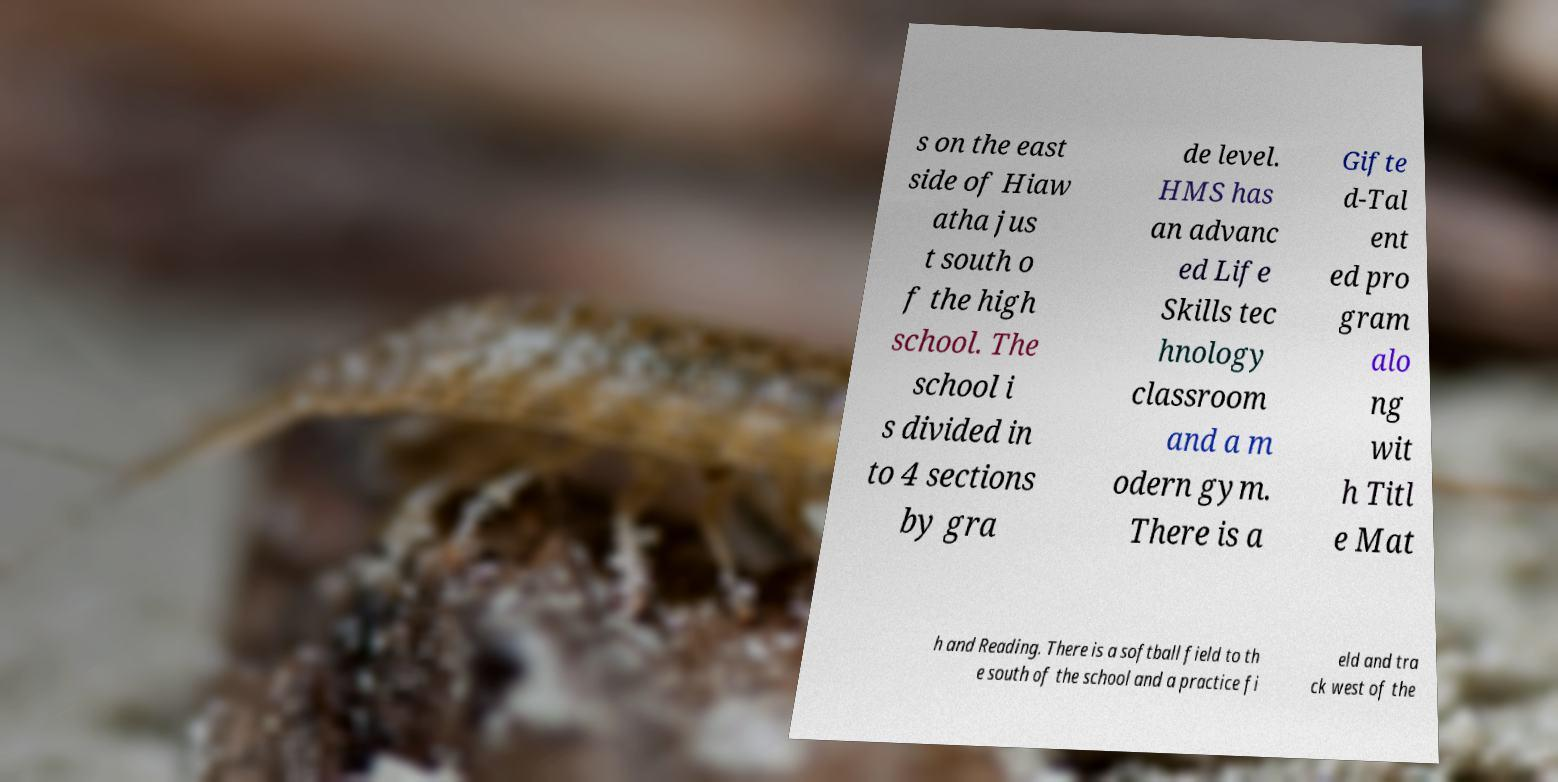There's text embedded in this image that I need extracted. Can you transcribe it verbatim? s on the east side of Hiaw atha jus t south o f the high school. The school i s divided in to 4 sections by gra de level. HMS has an advanc ed Life Skills tec hnology classroom and a m odern gym. There is a Gifte d-Tal ent ed pro gram alo ng wit h Titl e Mat h and Reading. There is a softball field to th e south of the school and a practice fi eld and tra ck west of the 